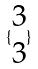Convert formula to latex. <formula><loc_0><loc_0><loc_500><loc_500>\{ \begin{matrix} 3 \\ 3 \end{matrix} \}</formula> 